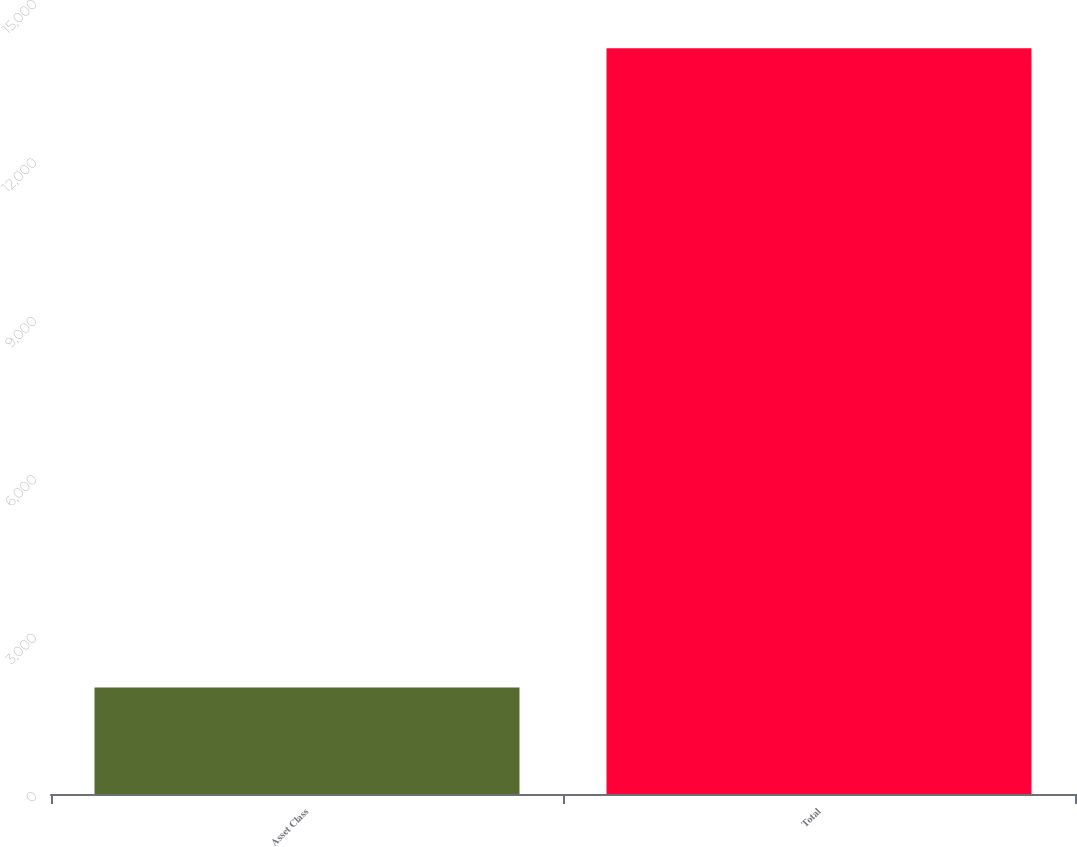Convert chart. <chart><loc_0><loc_0><loc_500><loc_500><bar_chart><fcel>Asset Class<fcel>Total<nl><fcel>2015<fcel>14125<nl></chart> 